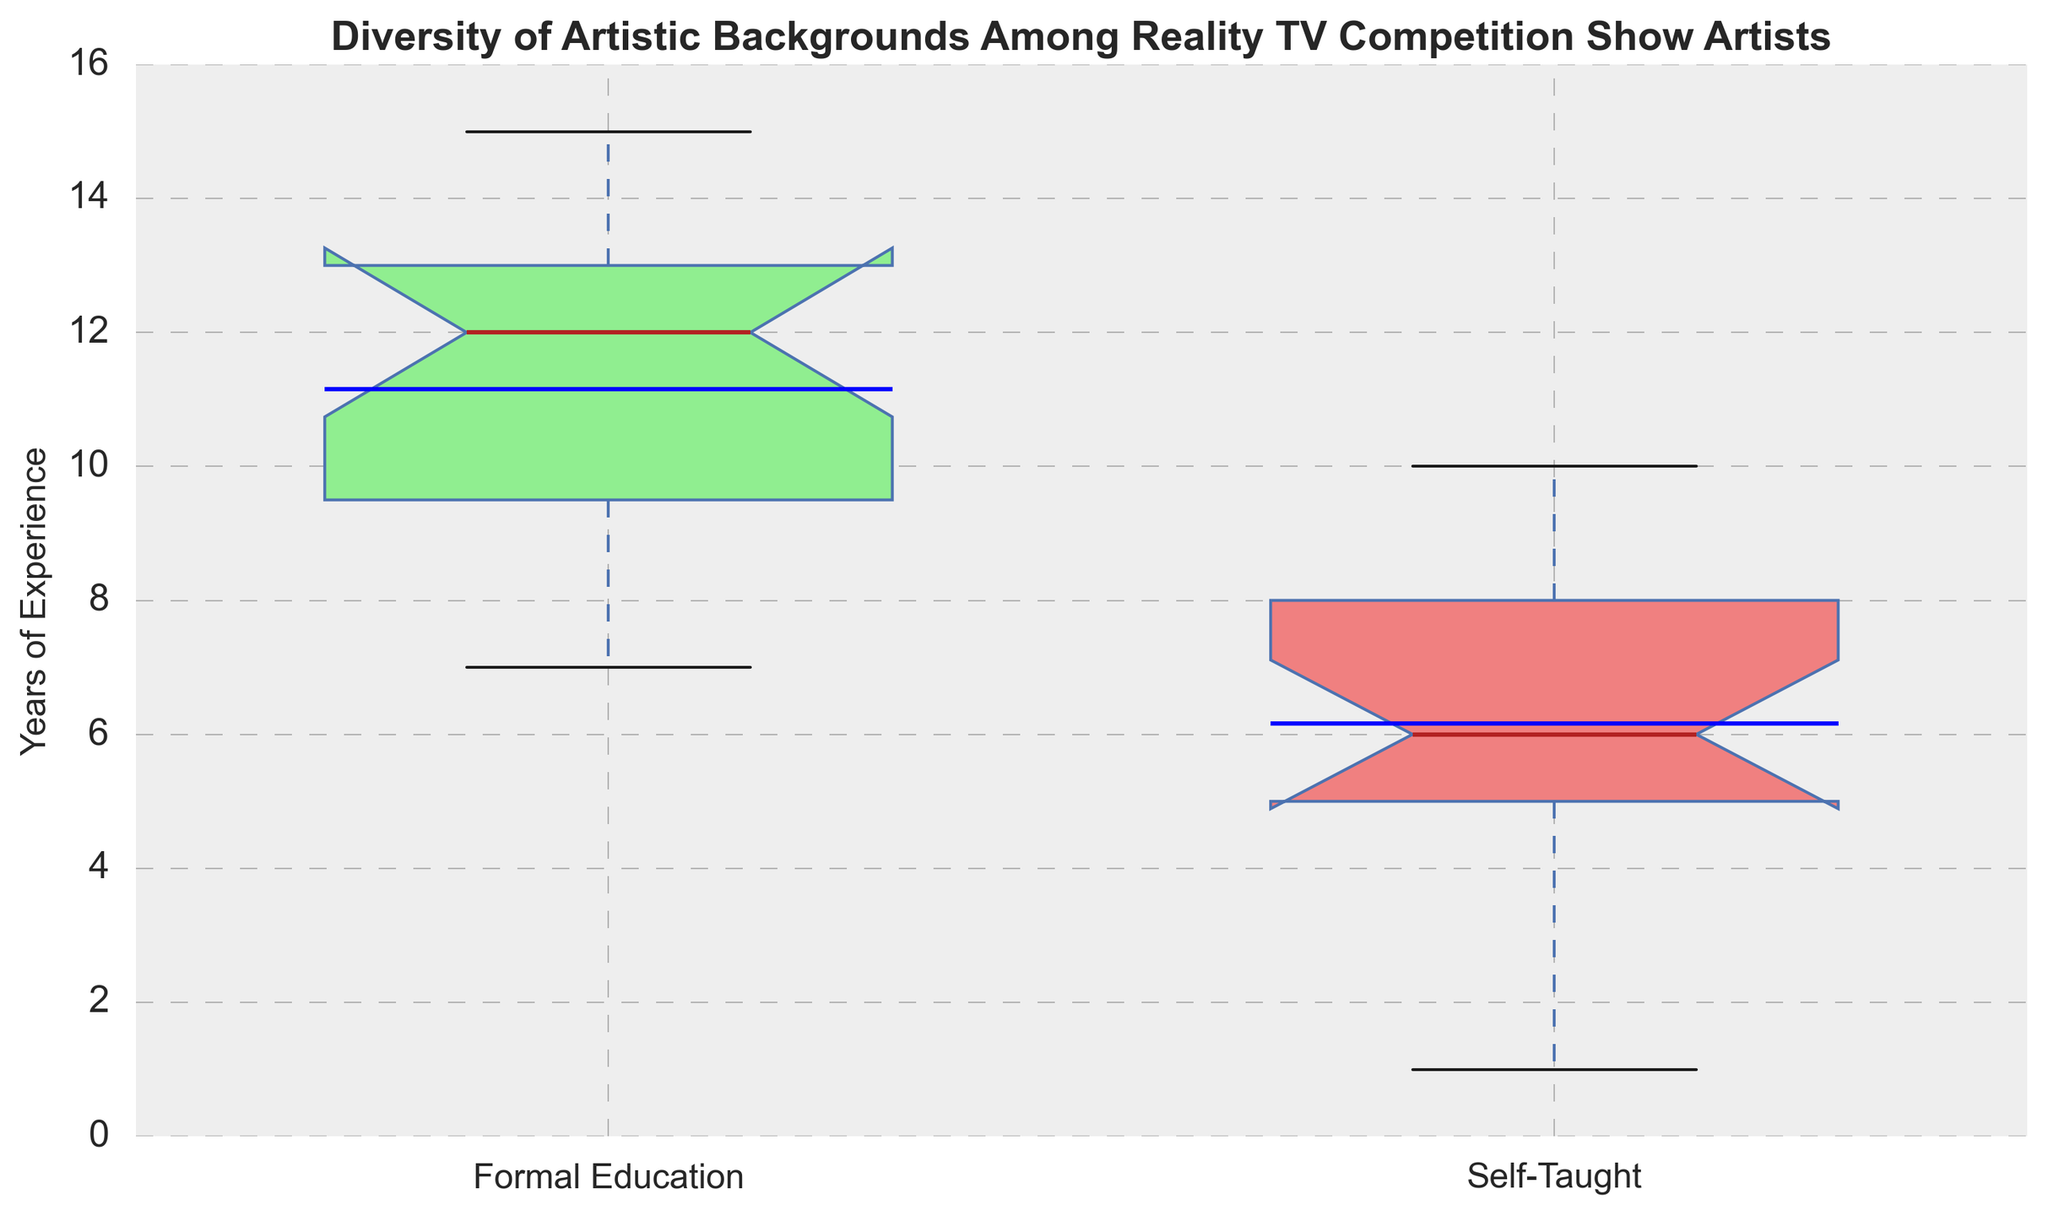What's the median years of experience for artists with formal education? The box plot for formal education shows a median line. To find the median, I need to locate the central line within the box plot of artists with formal education.
Answer: 12 Which group, formal education or self-taught, has the highest mean years of experience? The mean is marked by a line within the box, distinct from the median. The highest mean years of experience is indicated by comparing these mean lines across both groups.
Answer: Formal education What is the interquartile range (IQR) for artists who are self-taught? The IQR is the length of the box itself, representing the range between the first quartile (Q1) and third quartile (Q3). I need to measure the height of the box for self-taught artists.
Answer: 4 (7 - 3) Does one group have more outliers than the other? Outliers are represented by points outside the whiskers. To answer this, I count the number of points outside the whiskers for both groups.
Answer: No, both have similar outliers Is the median years of experience higher for self-taught or for formally educated artists? To determine this, I compare the central lines (medians) within the boxes of both groups.
Answer: Formally educated How does the spread of years of experience compare between the two groups? The spread is indicated by the length of the whiskers and the total height of the box. I compare these visual elements for both groups.
Answer: Larger for formally educated Which group has the smallest minimum years of experience? The minimum is indicated by the lower end of the whisker. Comparing both whiskers for the lower end and determining which is smaller.
Answer: Self-taught Are there more formally educated artists with years of experience above the median compared to self-taught artists? This involves looking at the upper half of both box plots (above the median line) and counting the number of data points visually indicated.
Answer: Yes Considering the upper quartile, which group has a greater range of years of experience? The upper quartile (Q3 to the maximum) is indicated by the top part of the whisker and box. The group with a longer upper part has a greater range.
Answer: Formally educated What's the difference between the medians of the two groups? Calculate the absolute difference between the median lines of the two groups. Median for formal is 12, and for self-taught is 6. So, 12 - 6 = 6 years.
Answer: 6 